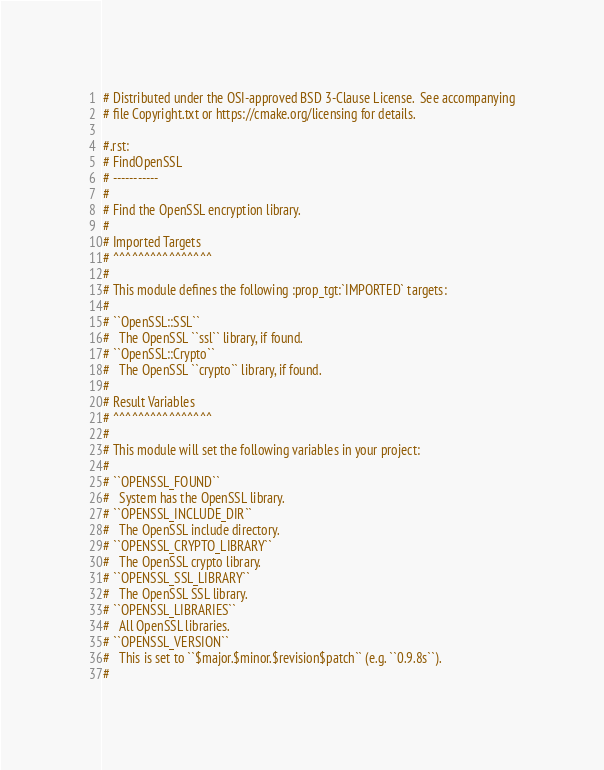Convert code to text. <code><loc_0><loc_0><loc_500><loc_500><_CMake_># Distributed under the OSI-approved BSD 3-Clause License.  See accompanying
# file Copyright.txt or https://cmake.org/licensing for details.

#.rst:
# FindOpenSSL
# -----------
#
# Find the OpenSSL encryption library.
#
# Imported Targets
# ^^^^^^^^^^^^^^^^
#
# This module defines the following :prop_tgt:`IMPORTED` targets:
#
# ``OpenSSL::SSL``
#   The OpenSSL ``ssl`` library, if found.
# ``OpenSSL::Crypto``
#   The OpenSSL ``crypto`` library, if found.
#
# Result Variables
# ^^^^^^^^^^^^^^^^
#
# This module will set the following variables in your project:
#
# ``OPENSSL_FOUND``
#   System has the OpenSSL library.
# ``OPENSSL_INCLUDE_DIR``
#   The OpenSSL include directory.
# ``OPENSSL_CRYPTO_LIBRARY``
#   The OpenSSL crypto library.
# ``OPENSSL_SSL_LIBRARY``
#   The OpenSSL SSL library.
# ``OPENSSL_LIBRARIES``
#   All OpenSSL libraries.
# ``OPENSSL_VERSION``
#   This is set to ``$major.$minor.$revision$patch`` (e.g. ``0.9.8s``).
#</code> 